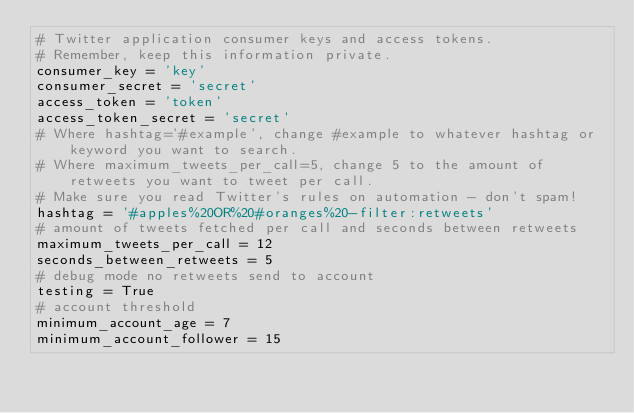Convert code to text. <code><loc_0><loc_0><loc_500><loc_500><_Python_># Twitter application consumer keys and access tokens.
# Remember, keep this information private.
consumer_key = 'key'
consumer_secret = 'secret'
access_token = 'token'
access_token_secret = 'secret'
# Where hashtag='#example', change #example to whatever hashtag or keyword you want to search.
# Where maximum_tweets_per_call=5, change 5 to the amount of retweets you want to tweet per call.
# Make sure you read Twitter's rules on automation - don't spam!
hashtag = '#apples%20OR%20#oranges%20-filter:retweets'
# amount of tweets fetched per call and seconds between retweets
maximum_tweets_per_call = 12
seconds_between_retweets = 5
# debug mode no retweets send to account
testing = True
# account threshold
minimum_account_age = 7
minimum_account_follower = 15
</code> 